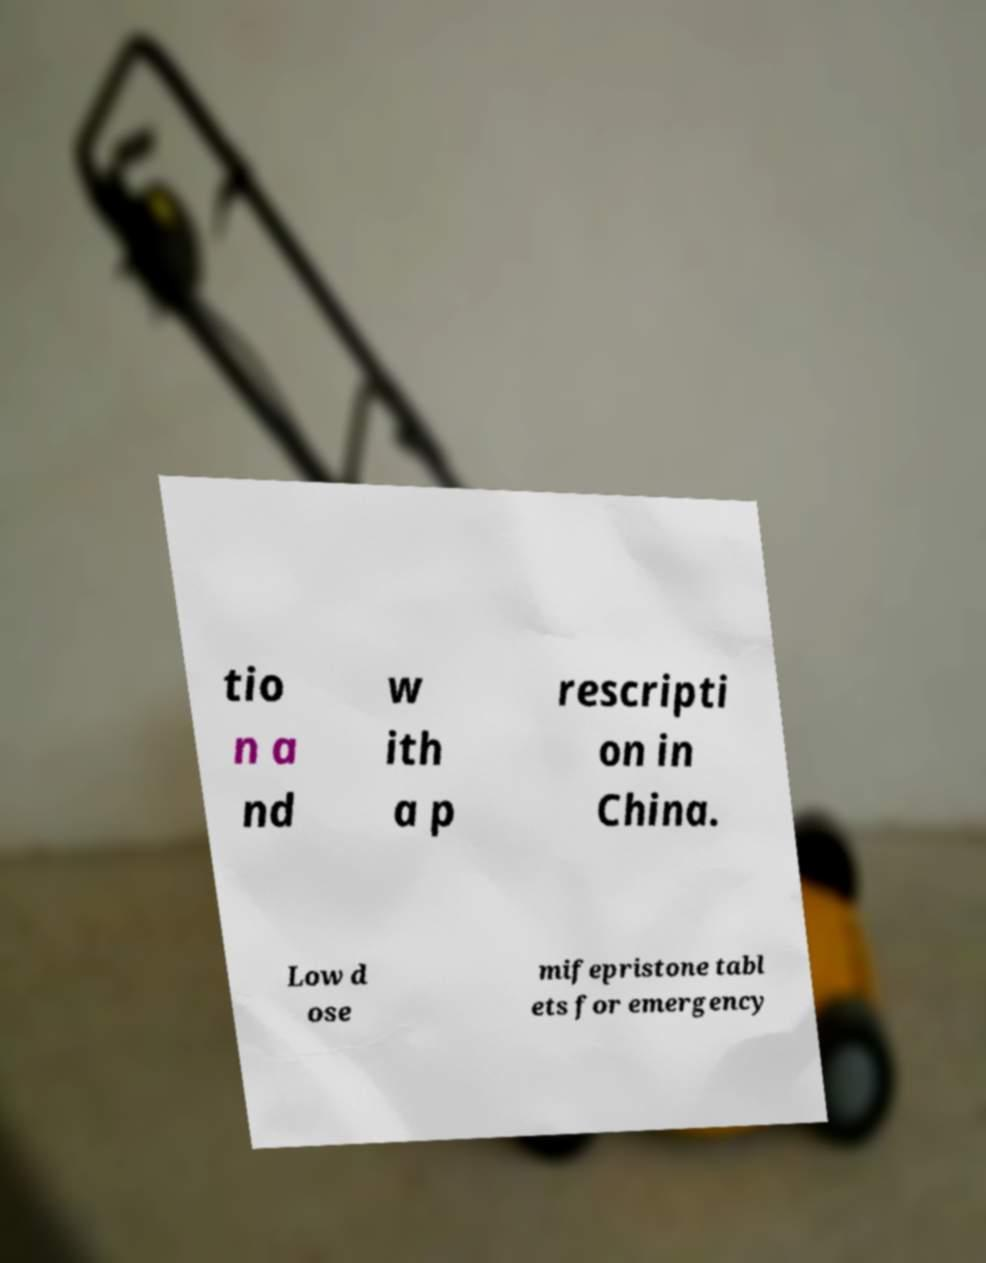Can you read and provide the text displayed in the image?This photo seems to have some interesting text. Can you extract and type it out for me? tio n a nd w ith a p rescripti on in China. Low d ose mifepristone tabl ets for emergency 